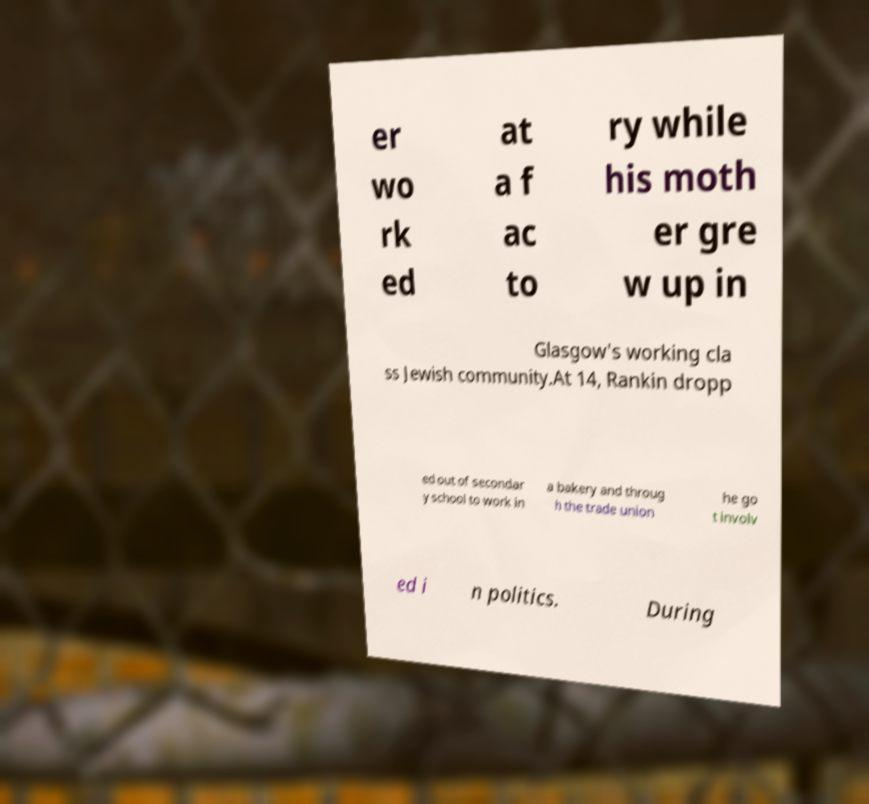There's text embedded in this image that I need extracted. Can you transcribe it verbatim? er wo rk ed at a f ac to ry while his moth er gre w up in Glasgow's working cla ss Jewish community.At 14, Rankin dropp ed out of secondar y school to work in a bakery and throug h the trade union he go t involv ed i n politics. During 